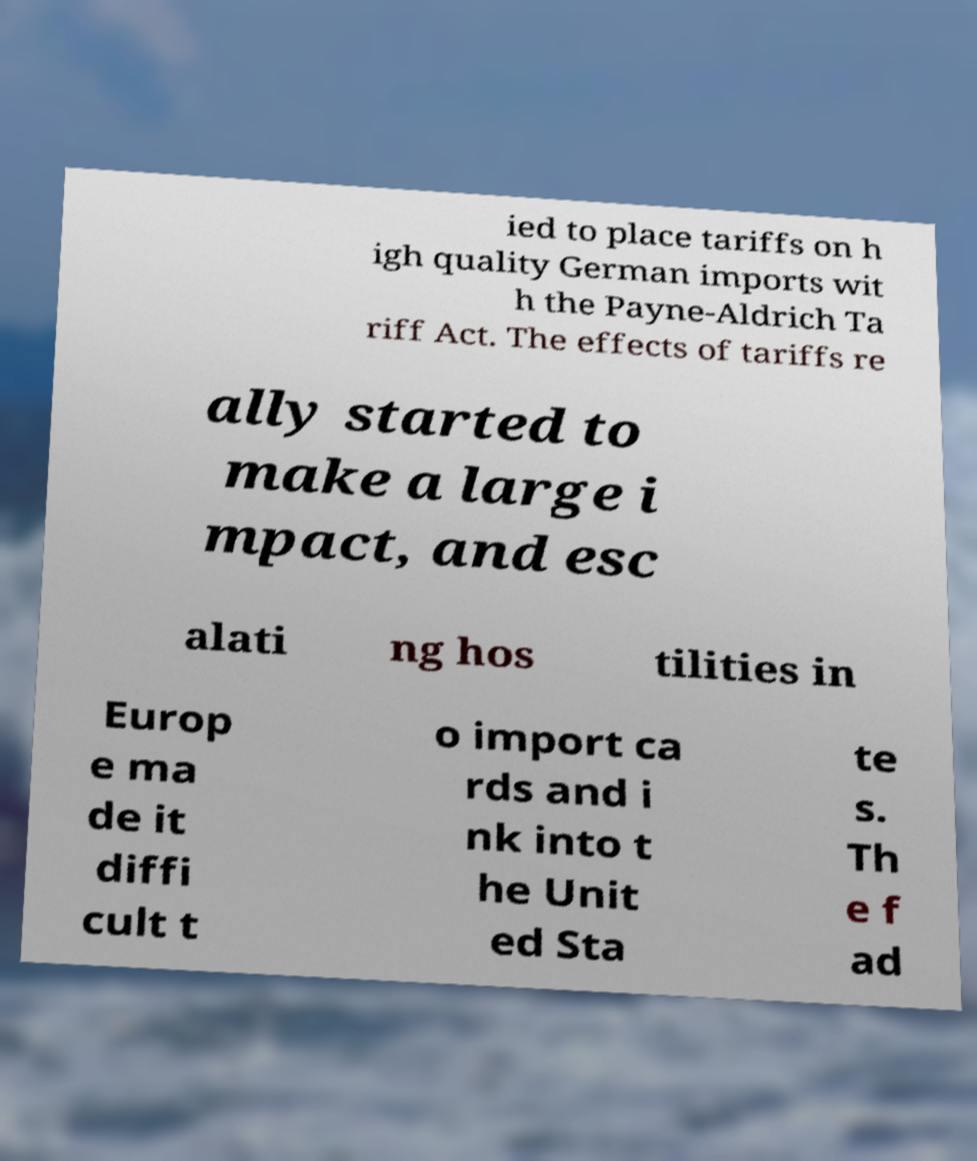Can you read and provide the text displayed in the image?This photo seems to have some interesting text. Can you extract and type it out for me? ied to place tariffs on h igh quality German imports wit h the Payne-Aldrich Ta riff Act. The effects of tariffs re ally started to make a large i mpact, and esc alati ng hos tilities in Europ e ma de it diffi cult t o import ca rds and i nk into t he Unit ed Sta te s. Th e f ad 